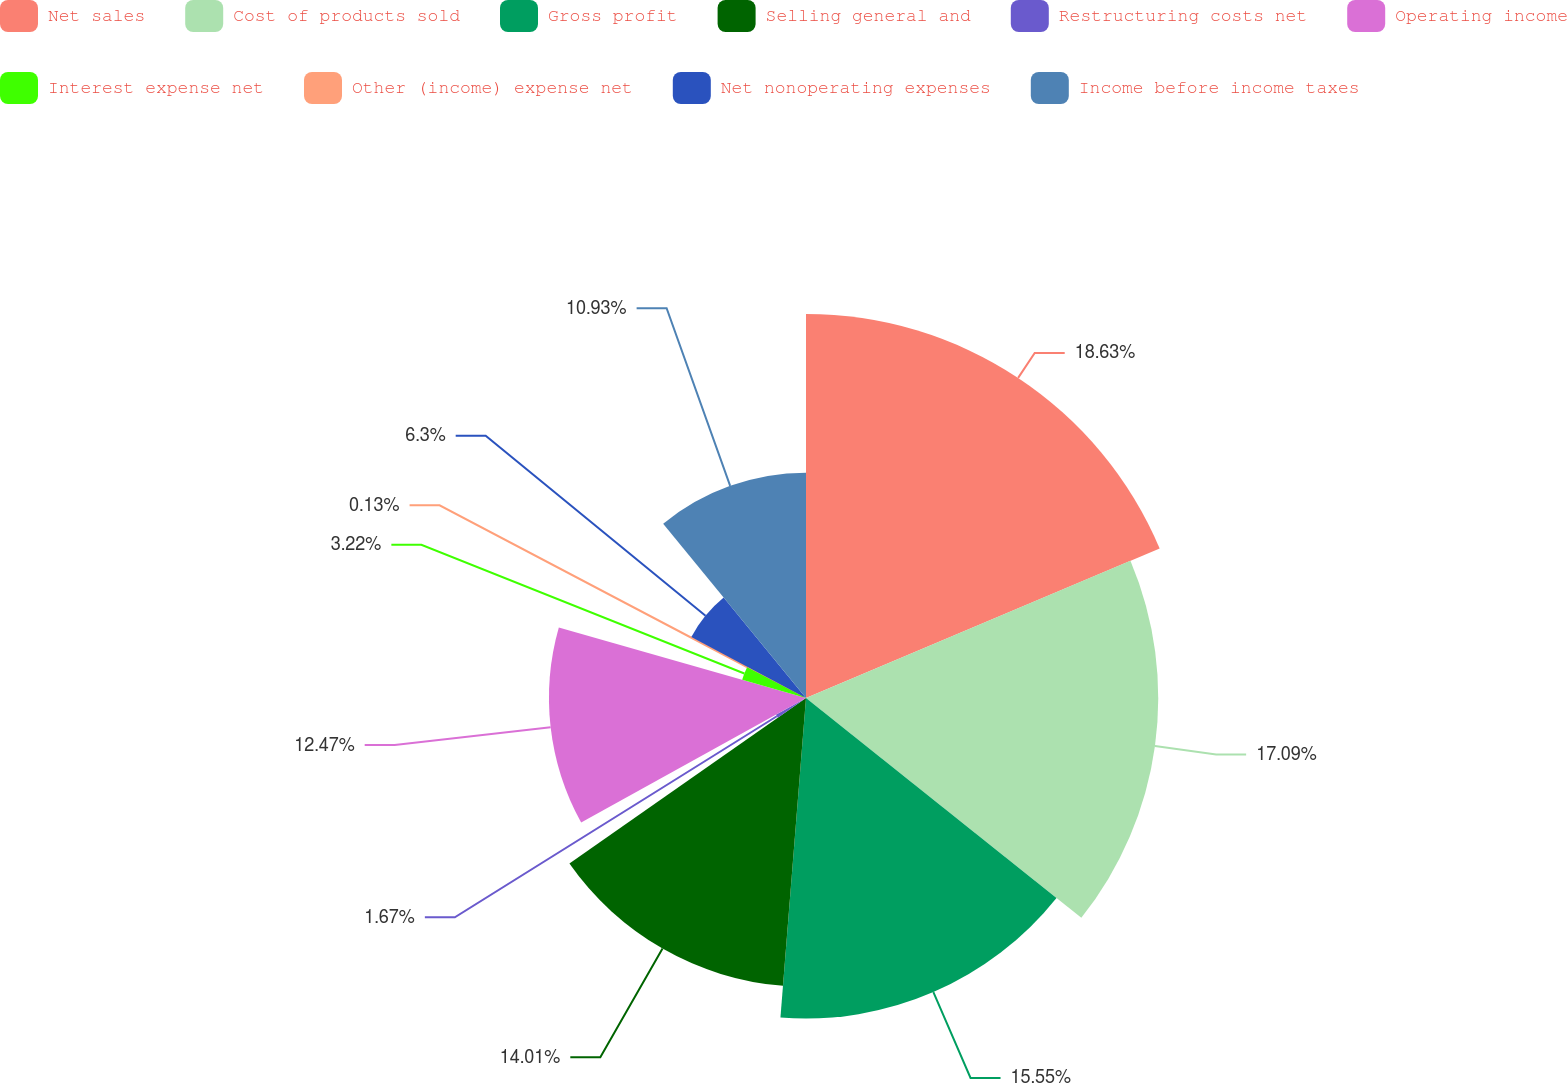<chart> <loc_0><loc_0><loc_500><loc_500><pie_chart><fcel>Net sales<fcel>Cost of products sold<fcel>Gross profit<fcel>Selling general and<fcel>Restructuring costs net<fcel>Operating income<fcel>Interest expense net<fcel>Other (income) expense net<fcel>Net nonoperating expenses<fcel>Income before income taxes<nl><fcel>18.63%<fcel>17.09%<fcel>15.55%<fcel>14.01%<fcel>1.67%<fcel>12.47%<fcel>3.22%<fcel>0.13%<fcel>6.3%<fcel>10.93%<nl></chart> 